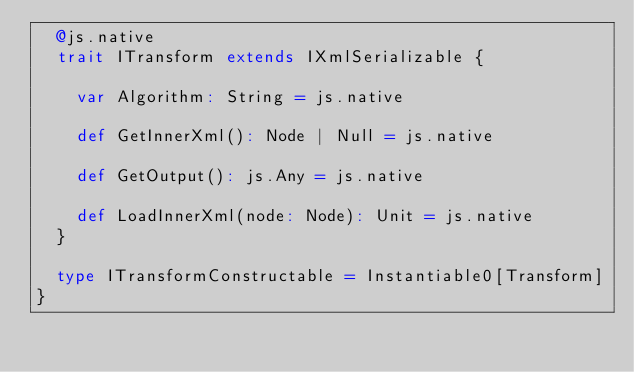Convert code to text. <code><loc_0><loc_0><loc_500><loc_500><_Scala_>  @js.native
  trait ITransform extends IXmlSerializable {
    
    var Algorithm: String = js.native
    
    def GetInnerXml(): Node | Null = js.native
    
    def GetOutput(): js.Any = js.native
    
    def LoadInnerXml(node: Node): Unit = js.native
  }
  
  type ITransformConstructable = Instantiable0[Transform]
}
</code> 